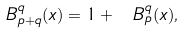Convert formula to latex. <formula><loc_0><loc_0><loc_500><loc_500>\ B _ { p + q } ^ { q } ( x ) = 1 + \ B _ { p } ^ { q } ( x ) ,</formula> 